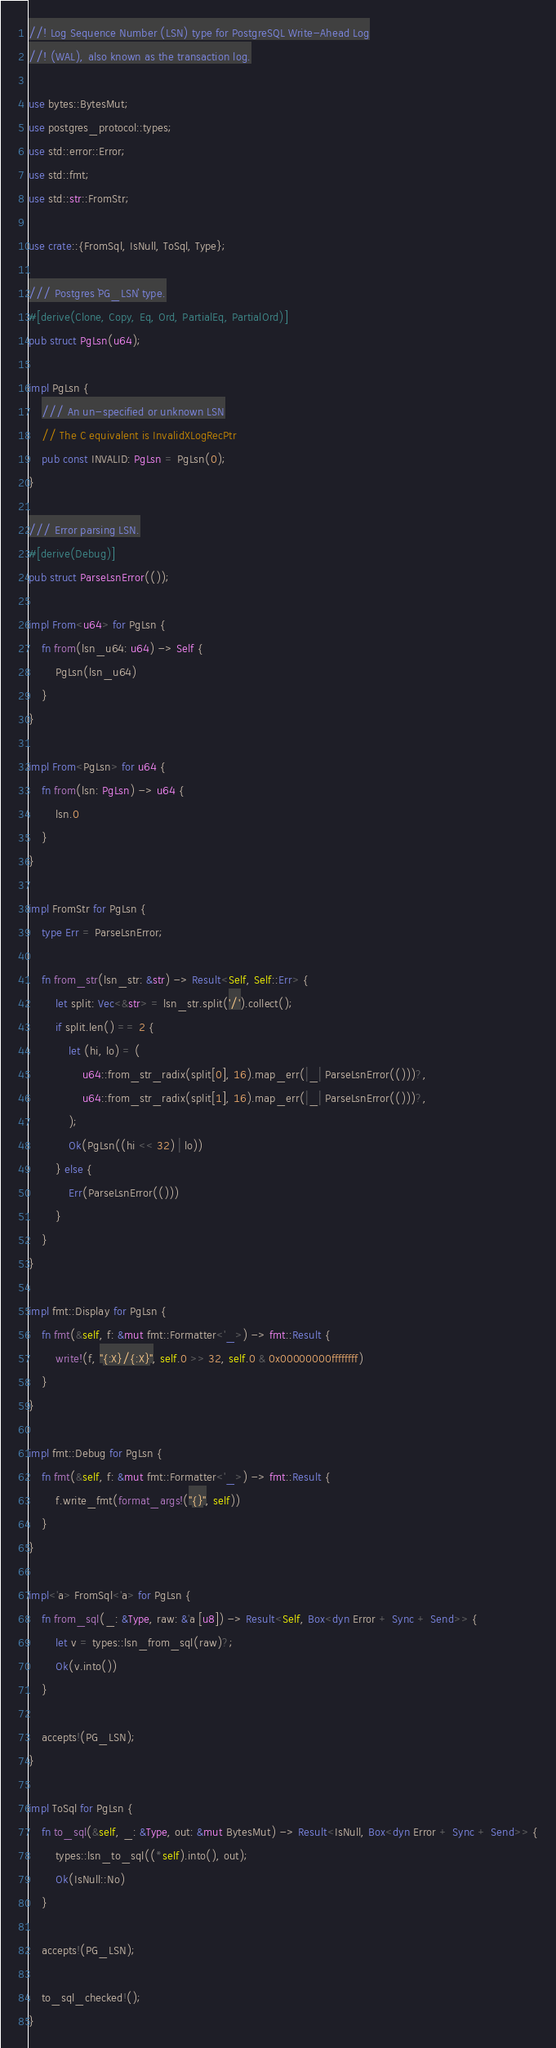Convert code to text. <code><loc_0><loc_0><loc_500><loc_500><_Rust_>//! Log Sequence Number (LSN) type for PostgreSQL Write-Ahead Log
//! (WAL), also known as the transaction log.

use bytes::BytesMut;
use postgres_protocol::types;
use std::error::Error;
use std::fmt;
use std::str::FromStr;

use crate::{FromSql, IsNull, ToSql, Type};

/// Postgres `PG_LSN` type.
#[derive(Clone, Copy, Eq, Ord, PartialEq, PartialOrd)]
pub struct PgLsn(u64);

impl PgLsn {
    /// An un-specified or unknown LSN
    // The C equivalent is InvalidXLogRecPtr
    pub const INVALID: PgLsn = PgLsn(0);
}

/// Error parsing LSN.
#[derive(Debug)]
pub struct ParseLsnError(());

impl From<u64> for PgLsn {
    fn from(lsn_u64: u64) -> Self {
        PgLsn(lsn_u64)
    }
}

impl From<PgLsn> for u64 {
    fn from(lsn: PgLsn) -> u64 {
        lsn.0
    }
}

impl FromStr for PgLsn {
    type Err = ParseLsnError;

    fn from_str(lsn_str: &str) -> Result<Self, Self::Err> {
        let split: Vec<&str> = lsn_str.split('/').collect();
        if split.len() == 2 {
            let (hi, lo) = (
                u64::from_str_radix(split[0], 16).map_err(|_| ParseLsnError(()))?,
                u64::from_str_radix(split[1], 16).map_err(|_| ParseLsnError(()))?,
            );
            Ok(PgLsn((hi << 32) | lo))
        } else {
            Err(ParseLsnError(()))
        }
    }
}

impl fmt::Display for PgLsn {
    fn fmt(&self, f: &mut fmt::Formatter<'_>) -> fmt::Result {
        write!(f, "{:X}/{:X}", self.0 >> 32, self.0 & 0x00000000ffffffff)
    }
}

impl fmt::Debug for PgLsn {
    fn fmt(&self, f: &mut fmt::Formatter<'_>) -> fmt::Result {
        f.write_fmt(format_args!("{}", self))
    }
}

impl<'a> FromSql<'a> for PgLsn {
    fn from_sql(_: &Type, raw: &'a [u8]) -> Result<Self, Box<dyn Error + Sync + Send>> {
        let v = types::lsn_from_sql(raw)?;
        Ok(v.into())
    }

    accepts!(PG_LSN);
}

impl ToSql for PgLsn {
    fn to_sql(&self, _: &Type, out: &mut BytesMut) -> Result<IsNull, Box<dyn Error + Sync + Send>> {
        types::lsn_to_sql((*self).into(), out);
        Ok(IsNull::No)
    }

    accepts!(PG_LSN);

    to_sql_checked!();
}
</code> 